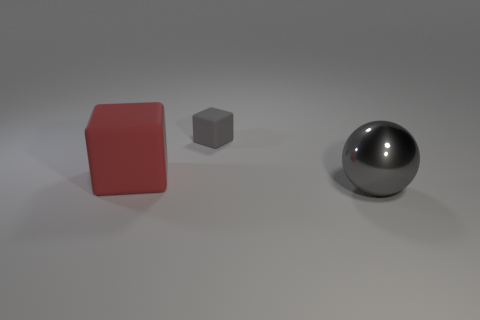There is a thing to the right of the small object; what color is it?
Your answer should be compact. Gray. There is a matte thing on the left side of the gray matte block; is it the same size as the big ball?
Your answer should be very brief. Yes. What size is the other rubber thing that is the same shape as the gray matte thing?
Make the answer very short. Large. Are there any other things that are the same size as the red matte block?
Give a very brief answer. Yes. Does the gray metal thing have the same shape as the tiny rubber object?
Your answer should be very brief. No. Are there fewer red matte objects that are to the right of the large gray sphere than large objects that are in front of the large matte thing?
Make the answer very short. Yes. There is a large cube; what number of gray spheres are right of it?
Give a very brief answer. 1. There is a thing that is behind the large red rubber thing; is its shape the same as the large thing that is left of the large shiny ball?
Your response must be concise. Yes. What number of other things are the same color as the metal ball?
Your answer should be compact. 1. What is the gray thing in front of the rubber cube that is in front of the block behind the large red rubber object made of?
Keep it short and to the point. Metal. 